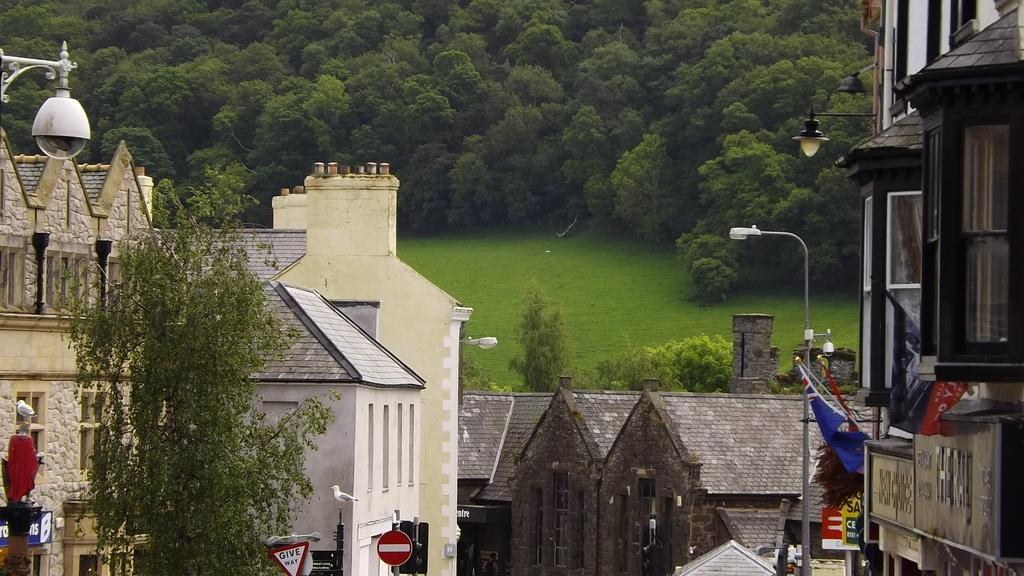In one or two sentences, can you explain what this image depicts? This is an outside view. At the bottom there are many buildings, light poles and trees and also I can see few boards. In the background, I can see the grass on the ground. At the top of the image there are many trees. 